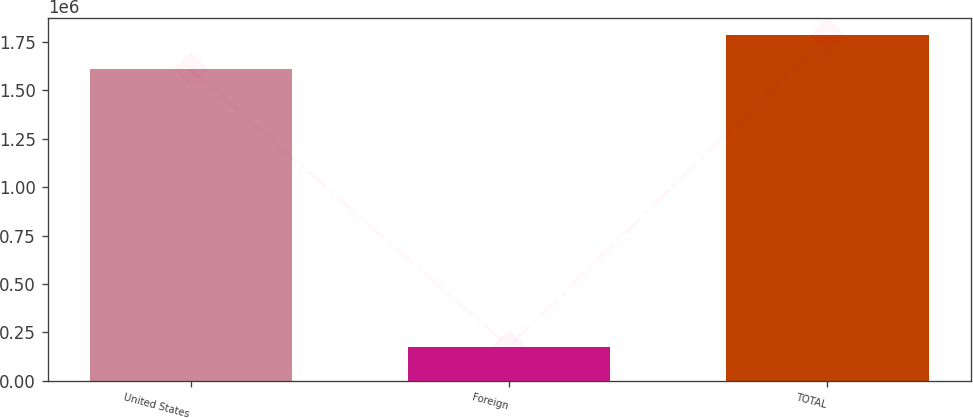Convert chart. <chart><loc_0><loc_0><loc_500><loc_500><bar_chart><fcel>United States<fcel>Foreign<fcel>TOTAL<nl><fcel>1.60693e+06<fcel>177074<fcel>1.784e+06<nl></chart> 